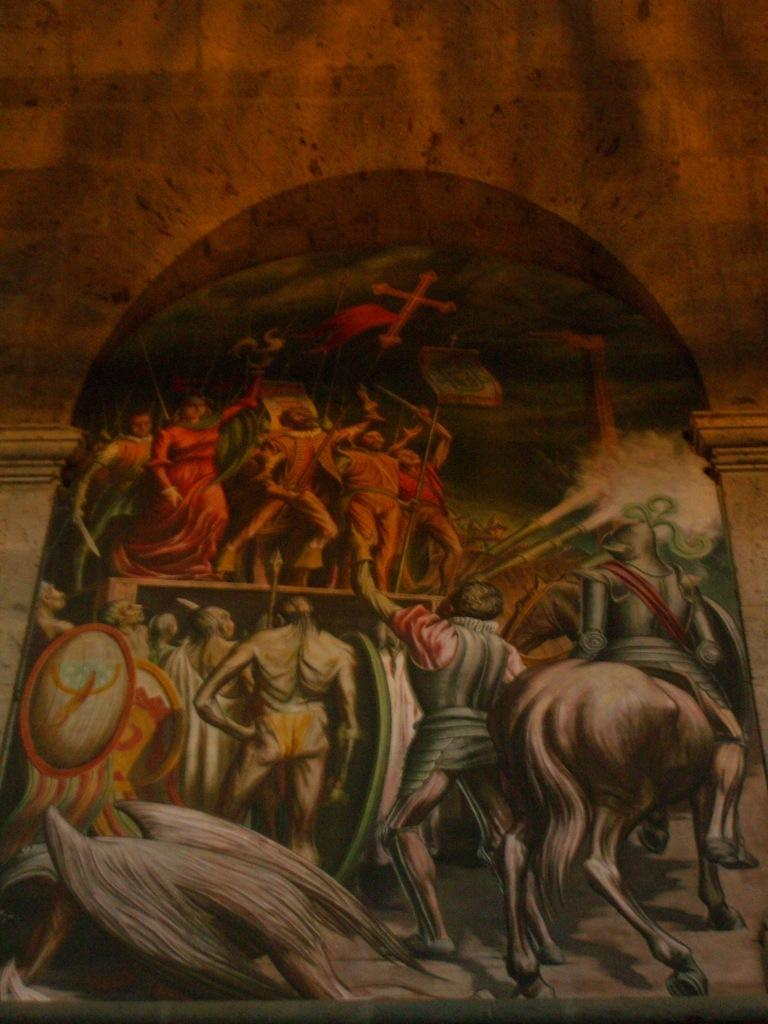What is the main subject of the image? The main subject of the image is a painting. What is depicted in the painting? The painting depicts persons and an animal. What can be seen in the background of the painting? There is a wall and pillars in the background of the painting. How many brothers are present in the painting? There is no mention of brothers in the painting; it depicts persons and an animal. What type of feast is being held in the painting? There is no indication of a feast in the painting; it simply shows persons, an animal, and background elements. 